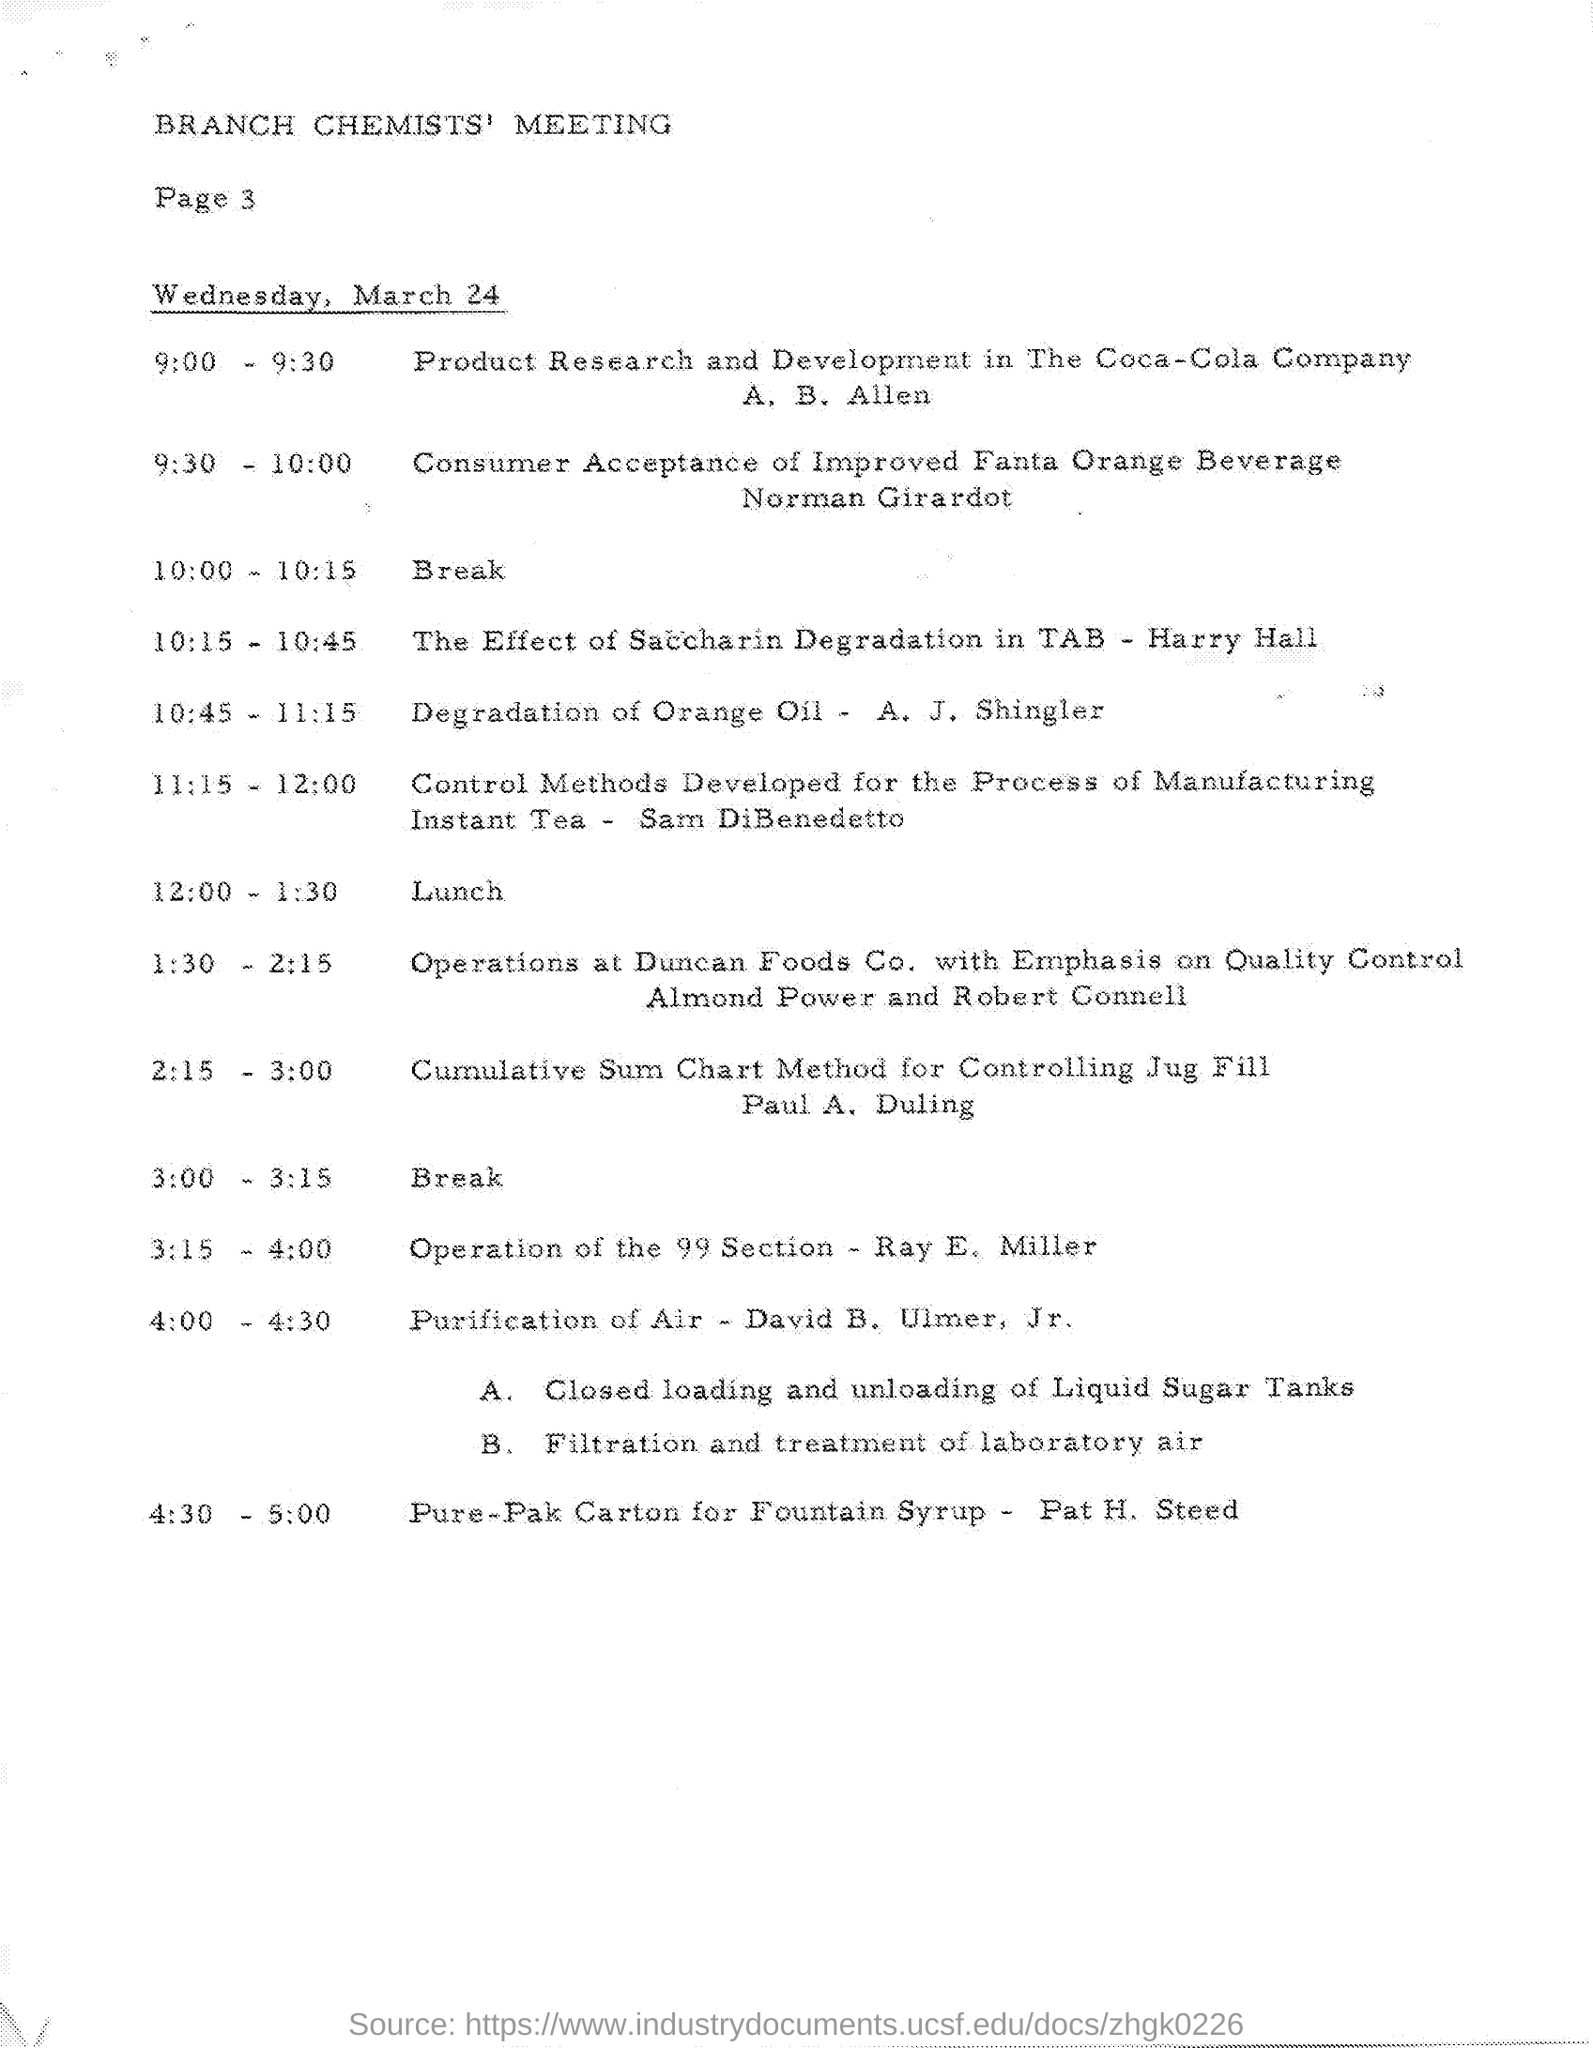Outline some significant characteristics in this image. Ray. E. Miller is leading the operation of Section 99. The topic "Purification of Air" will be discussed from 4:00 to 4:30. At 10:45 - 11:15, there was a degradation of orange oil. The title of the document is the Branch Chemists' meeting. 